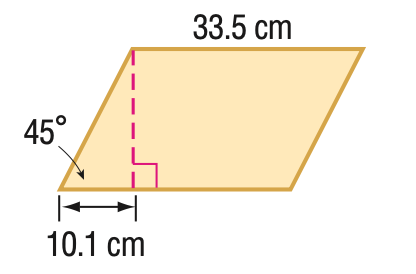Question: Find the area of the parallelogram. Round to the nearest tenth if necessary.
Choices:
A. 239.2
B. 338.4
C. 478.5
D. 586.0
Answer with the letter. Answer: B 